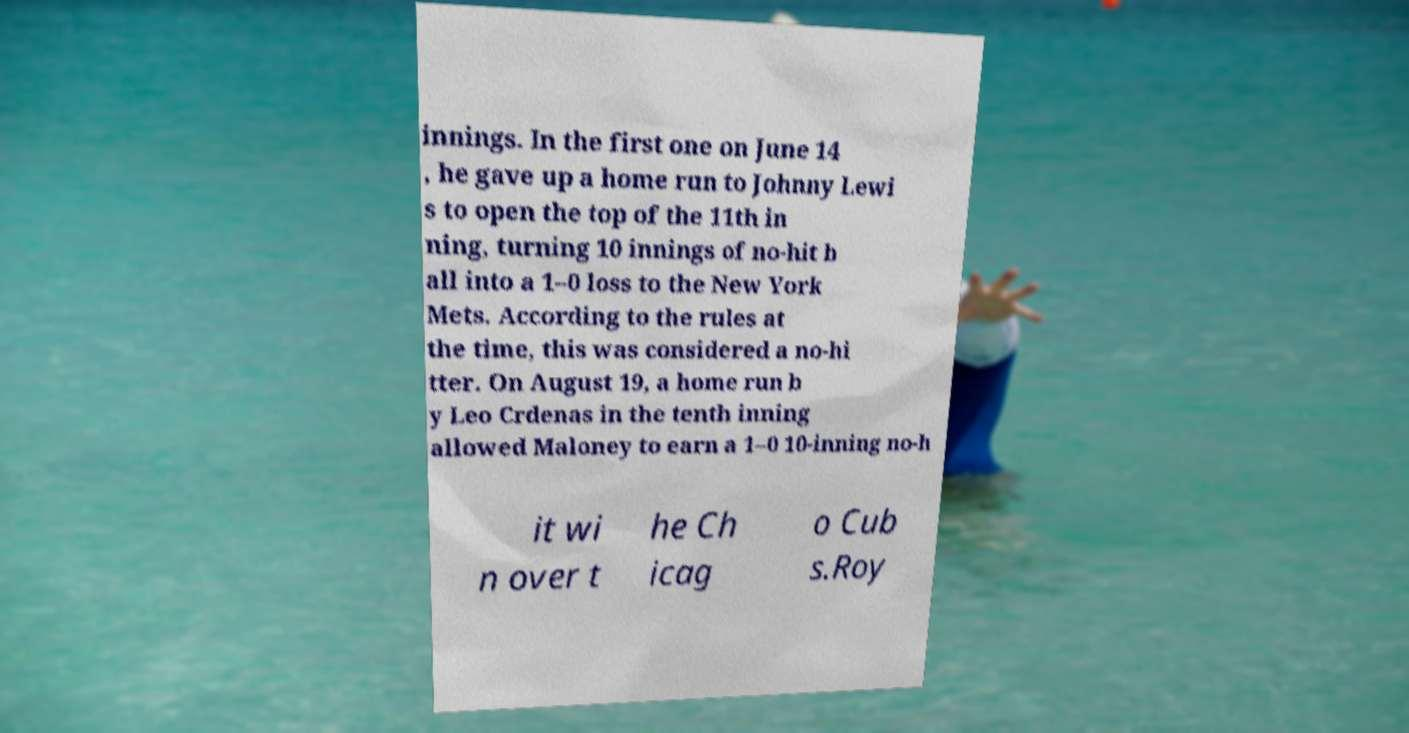Could you extract and type out the text from this image? innings. In the first one on June 14 , he gave up a home run to Johnny Lewi s to open the top of the 11th in ning, turning 10 innings of no-hit b all into a 1–0 loss to the New York Mets. According to the rules at the time, this was considered a no-hi tter. On August 19, a home run b y Leo Crdenas in the tenth inning allowed Maloney to earn a 1–0 10-inning no-h it wi n over t he Ch icag o Cub s.Roy 